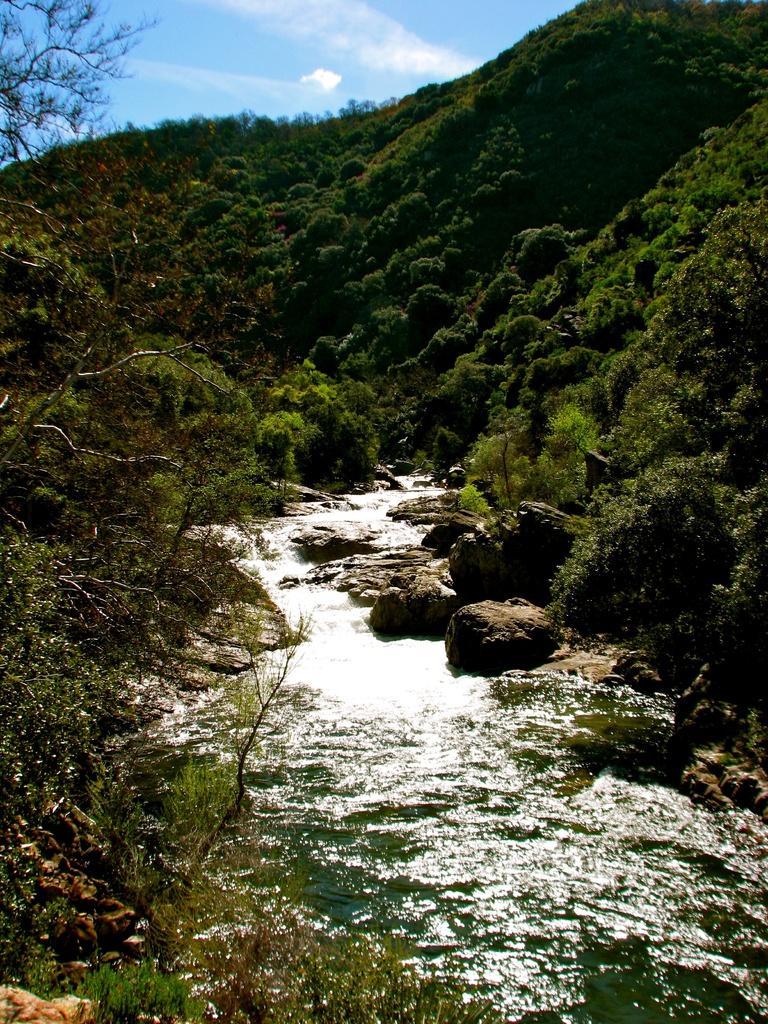In one or two sentences, can you explain what this image depicts? In this image there are mountains. There are trees and plants on the mountains. In the center there is water flowing. There are rocks beside the water. At the top there is the sky. 